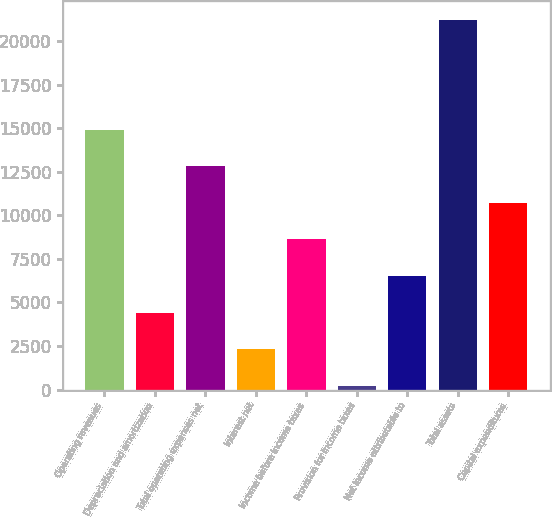Convert chart. <chart><loc_0><loc_0><loc_500><loc_500><bar_chart><fcel>Operating revenues<fcel>Depreciation and amortization<fcel>Total operating expenses net<fcel>Interest net<fcel>Income before income taxes<fcel>Provision for income taxes<fcel>Net income attributable to<fcel>Total assets<fcel>Capital expenditures<nl><fcel>14922.7<fcel>4422.2<fcel>12822.6<fcel>2322.1<fcel>8622.4<fcel>222<fcel>6522.3<fcel>21223<fcel>10722.5<nl></chart> 